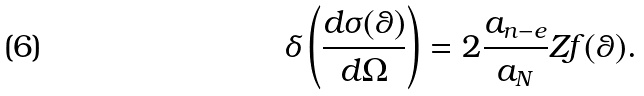<formula> <loc_0><loc_0><loc_500><loc_500>\delta \left ( \frac { d \sigma ( \theta ) } { d \Omega } \right ) = 2 \frac { a _ { n - e } } { a _ { N } } Z f ( \theta ) .</formula> 